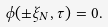<formula> <loc_0><loc_0><loc_500><loc_500>\phi ( \pm \xi _ { N } , \tau ) = 0 .</formula> 